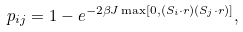Convert formula to latex. <formula><loc_0><loc_0><loc_500><loc_500>p _ { i j } = 1 - e ^ { - 2 \beta J \max [ 0 , ( { S } _ { i } \cdot { r } ) ( { S } _ { j } \cdot { r } ) ] } ,</formula> 